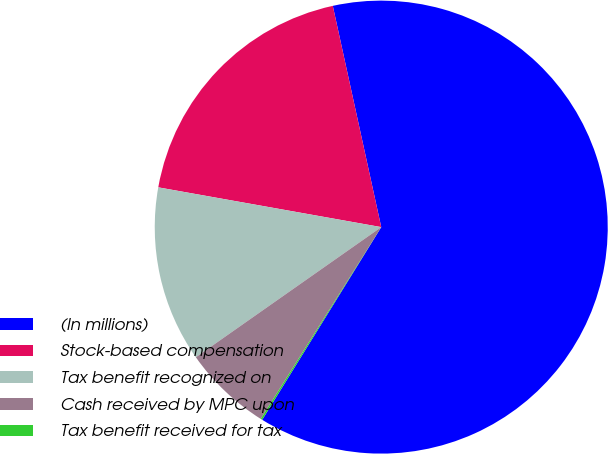<chart> <loc_0><loc_0><loc_500><loc_500><pie_chart><fcel>(In millions)<fcel>Stock-based compensation<fcel>Tax benefit recognized on<fcel>Cash received by MPC upon<fcel>Tax benefit received for tax<nl><fcel>62.24%<fcel>18.76%<fcel>12.55%<fcel>6.33%<fcel>0.12%<nl></chart> 